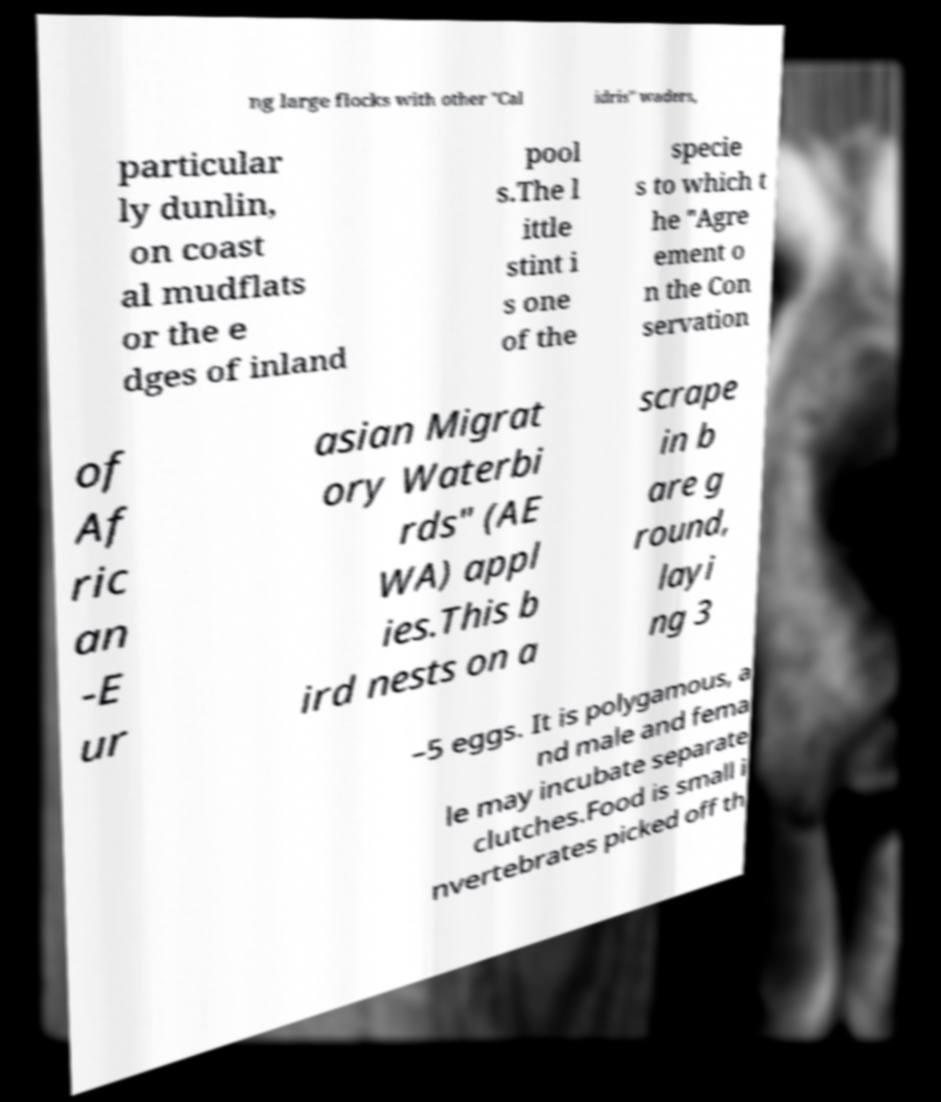Could you extract and type out the text from this image? ng large flocks with other "Cal idris" waders, particular ly dunlin, on coast al mudflats or the e dges of inland pool s.The l ittle stint i s one of the specie s to which t he "Agre ement o n the Con servation of Af ric an -E ur asian Migrat ory Waterbi rds" (AE WA) appl ies.This b ird nests on a scrape in b are g round, layi ng 3 –5 eggs. It is polygamous, a nd male and fema le may incubate separate clutches.Food is small i nvertebrates picked off th 